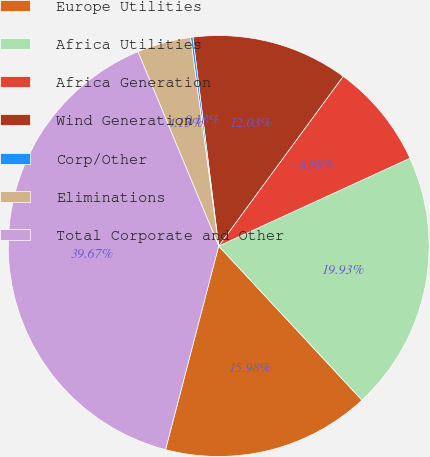<chart> <loc_0><loc_0><loc_500><loc_500><pie_chart><fcel>Europe Utilities<fcel>Africa Utilities<fcel>Africa Generation<fcel>Wind Generation<fcel>Corp/Other<fcel>Eliminations<fcel>Total Corporate and Other<nl><fcel>15.98%<fcel>19.93%<fcel>8.08%<fcel>12.03%<fcel>0.18%<fcel>4.13%<fcel>39.67%<nl></chart> 